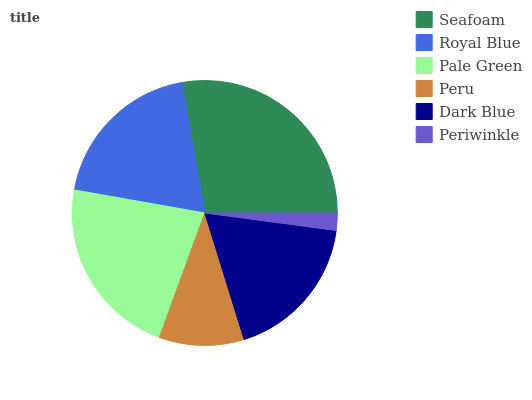Is Periwinkle the minimum?
Answer yes or no. Yes. Is Seafoam the maximum?
Answer yes or no. Yes. Is Royal Blue the minimum?
Answer yes or no. No. Is Royal Blue the maximum?
Answer yes or no. No. Is Seafoam greater than Royal Blue?
Answer yes or no. Yes. Is Royal Blue less than Seafoam?
Answer yes or no. Yes. Is Royal Blue greater than Seafoam?
Answer yes or no. No. Is Seafoam less than Royal Blue?
Answer yes or no. No. Is Royal Blue the high median?
Answer yes or no. Yes. Is Dark Blue the low median?
Answer yes or no. Yes. Is Peru the high median?
Answer yes or no. No. Is Periwinkle the low median?
Answer yes or no. No. 